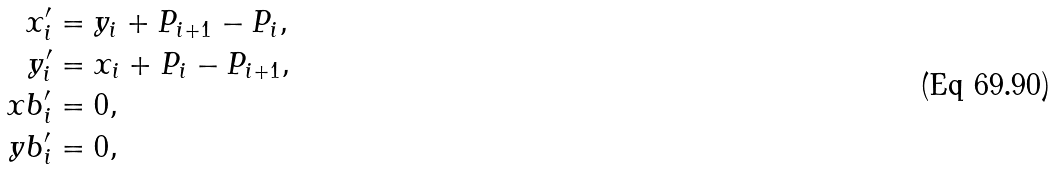<formula> <loc_0><loc_0><loc_500><loc_500>x _ { i } ^ { \prime } & = y _ { i } + P _ { i + 1 } - P _ { i } , \\ y _ { i } ^ { \prime } & = x _ { i } + P _ { i } - P _ { i + 1 } , \\ \ x b _ { i } ^ { \prime } & = 0 , \\ \ y b _ { i } ^ { \prime } & = 0 ,</formula> 